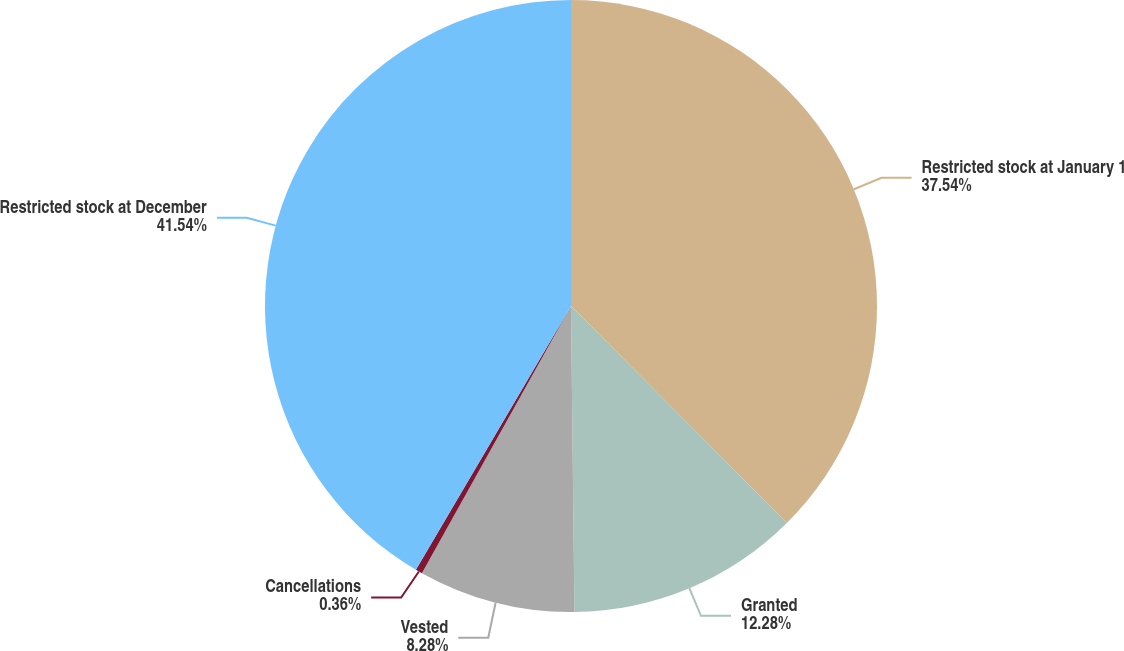Convert chart to OTSL. <chart><loc_0><loc_0><loc_500><loc_500><pie_chart><fcel>Restricted stock at January 1<fcel>Granted<fcel>Vested<fcel>Cancellations<fcel>Restricted stock at December<nl><fcel>37.54%<fcel>12.28%<fcel>8.28%<fcel>0.36%<fcel>41.54%<nl></chart> 